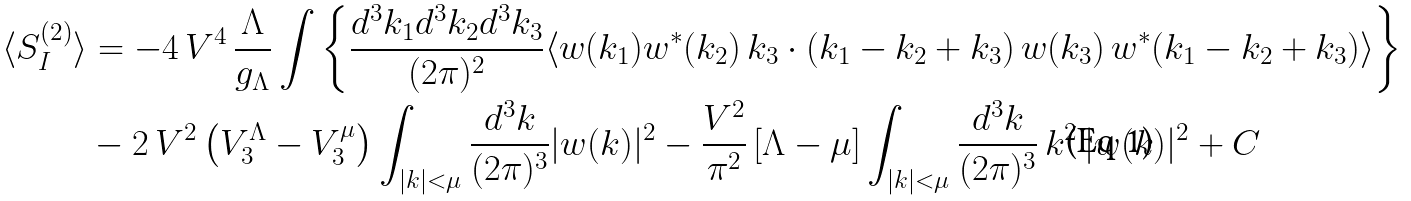<formula> <loc_0><loc_0><loc_500><loc_500>\langle S _ { I } ^ { ( 2 ) } \rangle & = - 4 \, V ^ { 4 } \, \frac { \Lambda } { g _ { \Lambda } } \int \left \{ \frac { d ^ { 3 } k _ { 1 } d ^ { 3 } k _ { 2 } d ^ { 3 } k _ { 3 } } { ( 2 \pi ) ^ { 2 } } \langle w ( k _ { 1 } ) w ^ { * } ( k _ { 2 } ) \, k _ { 3 } \cdot ( k _ { 1 } - k _ { 2 } + k _ { 3 } ) \, w ( k _ { 3 } ) \, w ^ { * } ( k _ { 1 } - k _ { 2 } + k _ { 3 } ) \rangle \right \} \\ & - 2 \, V ^ { 2 } \left ( V _ { 3 } ^ { \Lambda } - V _ { 3 } ^ { \mu } \right ) \int _ { | k | < \mu } \frac { d ^ { 3 } k } { ( 2 \pi ) ^ { 3 } } | w ( k ) | ^ { 2 } - \frac { V ^ { 2 } } { \pi ^ { 2 } } \left [ \Lambda - \mu \right ] \int _ { | k | < \mu } \frac { d ^ { 3 } k } { ( 2 \pi ) ^ { 3 } } \, k ^ { 2 } \, | w ( k ) | ^ { 2 } + C</formula> 